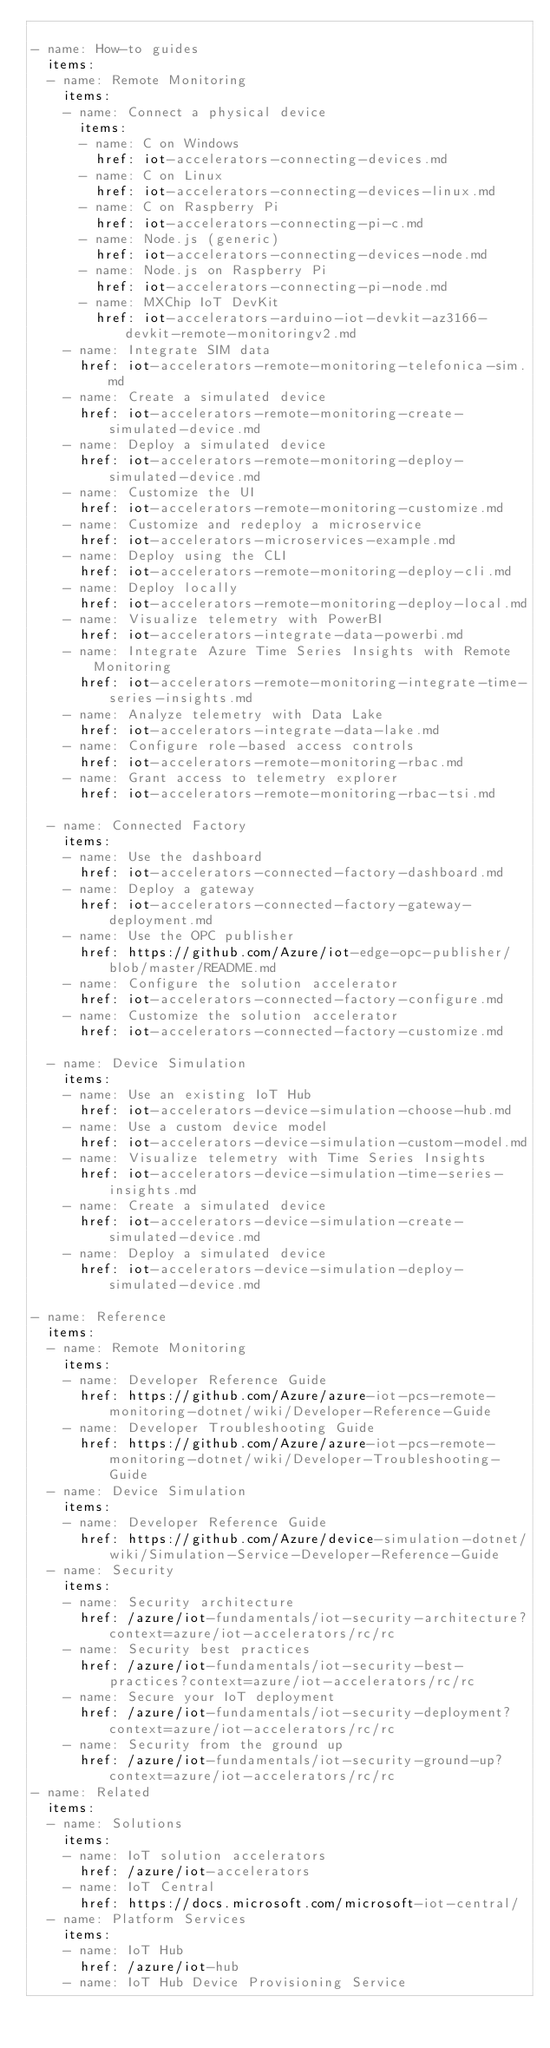Convert code to text. <code><loc_0><loc_0><loc_500><loc_500><_YAML_>
- name: How-to guides
  items:
  - name: Remote Monitoring
    items:
    - name: Connect a physical device
      items:
      - name: C on Windows
        href: iot-accelerators-connecting-devices.md
      - name: C on Linux
        href: iot-accelerators-connecting-devices-linux.md
      - name: C on Raspberry Pi
        href: iot-accelerators-connecting-pi-c.md
      - name: Node.js (generic)
        href: iot-accelerators-connecting-devices-node.md
      - name: Node.js on Raspberry Pi
        href: iot-accelerators-connecting-pi-node.md
      - name: MXChip IoT DevKit
        href: iot-accelerators-arduino-iot-devkit-az3166-devkit-remote-monitoringv2.md
    - name: Integrate SIM data
      href: iot-accelerators-remote-monitoring-telefonica-sim.md
    - name: Create a simulated device
      href: iot-accelerators-remote-monitoring-create-simulated-device.md
    - name: Deploy a simulated device
      href: iot-accelerators-remote-monitoring-deploy-simulated-device.md
    - name: Customize the UI
      href: iot-accelerators-remote-monitoring-customize.md
    - name: Customize and redeploy a microservice
      href: iot-accelerators-microservices-example.md
    - name: Deploy using the CLI
      href: iot-accelerators-remote-monitoring-deploy-cli.md
    - name: Deploy locally
      href: iot-accelerators-remote-monitoring-deploy-local.md
    - name: Visualize telemetry with PowerBI
      href: iot-accelerators-integrate-data-powerbi.md
    - name: Integrate Azure Time Series Insights with Remote Monitoring
      href: iot-accelerators-remote-monitoring-integrate-time-series-insights.md
    - name: Analyze telemetry with Data Lake
      href: iot-accelerators-integrate-data-lake.md
    - name: Configure role-based access controls
      href: iot-accelerators-remote-monitoring-rbac.md
    - name: Grant access to telemetry explorer
      href: iot-accelerators-remote-monitoring-rbac-tsi.md

  - name: Connected Factory
    items:
    - name: Use the dashboard
      href: iot-accelerators-connected-factory-dashboard.md
    - name: Deploy a gateway
      href: iot-accelerators-connected-factory-gateway-deployment.md
    - name: Use the OPC publisher
      href: https://github.com/Azure/iot-edge-opc-publisher/blob/master/README.md
    - name: Configure the solution accelerator
      href: iot-accelerators-connected-factory-configure.md
    - name: Customize the solution accelerator
      href: iot-accelerators-connected-factory-customize.md

  - name: Device Simulation
    items:
    - name: Use an existing IoT Hub
      href: iot-accelerators-device-simulation-choose-hub.md
    - name: Use a custom device model
      href: iot-accelerators-device-simulation-custom-model.md
    - name: Visualize telemetry with Time Series Insights
      href: iot-accelerators-device-simulation-time-series-insights.md
    - name: Create a simulated device
      href: iot-accelerators-device-simulation-create-simulated-device.md
    - name: Deploy a simulated device
      href: iot-accelerators-device-simulation-deploy-simulated-device.md

- name: Reference
  items:
  - name: Remote Monitoring
    items:
    - name: Developer Reference Guide
      href: https://github.com/Azure/azure-iot-pcs-remote-monitoring-dotnet/wiki/Developer-Reference-Guide
    - name: Developer Troubleshooting Guide
      href: https://github.com/Azure/azure-iot-pcs-remote-monitoring-dotnet/wiki/Developer-Troubleshooting-Guide
  - name: Device Simulation
    items:
    - name: Developer Reference Guide
      href: https://github.com/Azure/device-simulation-dotnet/wiki/Simulation-Service-Developer-Reference-Guide
  - name: Security
    items:
    - name: Security architecture
      href: /azure/iot-fundamentals/iot-security-architecture?context=azure/iot-accelerators/rc/rc
    - name: Security best practices
      href: /azure/iot-fundamentals/iot-security-best-practices?context=azure/iot-accelerators/rc/rc
    - name: Secure your IoT deployment
      href: /azure/iot-fundamentals/iot-security-deployment?context=azure/iot-accelerators/rc/rc
    - name: Security from the ground up
      href: /azure/iot-fundamentals/iot-security-ground-up?context=azure/iot-accelerators/rc/rc
- name: Related
  items:
  - name: Solutions
    items:
    - name: IoT solution accelerators
      href: /azure/iot-accelerators 
    - name: IoT Central
      href: https://docs.microsoft.com/microsoft-iot-central/ 
  - name: Platform Services 
    items:
    - name: IoT Hub
      href: /azure/iot-hub 
    - name: IoT Hub Device Provisioning Service</code> 